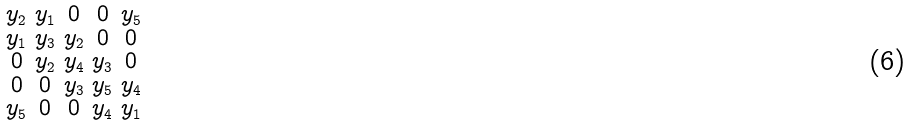<formula> <loc_0><loc_0><loc_500><loc_500>\begin{smallmatrix} y _ { 2 } & y _ { 1 } & 0 & 0 & y _ { 5 } \\ y _ { 1 } & y _ { 3 } & y _ { 2 } & 0 & 0 \\ 0 & y _ { 2 } & y _ { 4 } & y _ { 3 } & 0 \\ 0 & 0 & y _ { 3 } & y _ { 5 } & y _ { 4 } \\ y _ { 5 } & 0 & 0 & y _ { 4 } & y _ { 1 } \end{smallmatrix}</formula> 